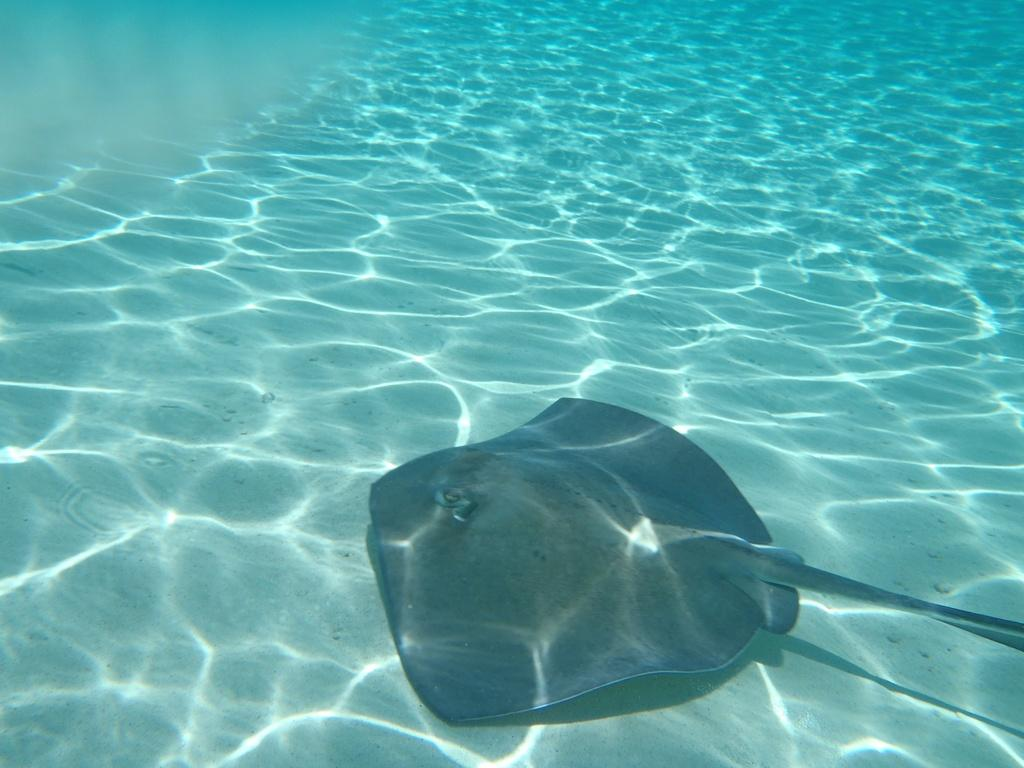What type of animal can be seen in the water in the image? There is a fish in the water in the image. What type of family can be seen gathering around the clam in the image? There is no clam or family present in the image; it only features a fish in the water. 